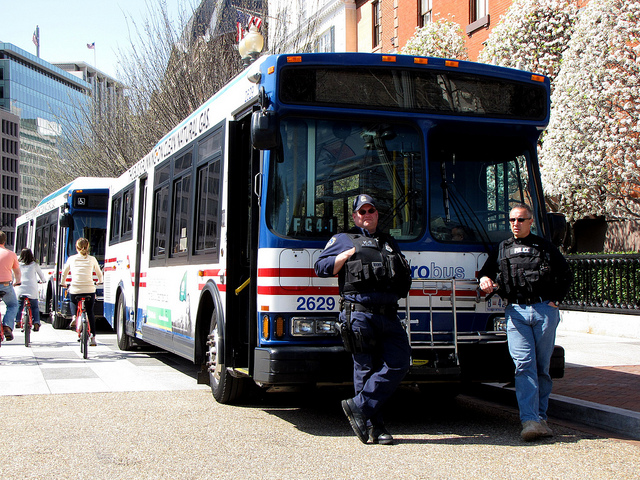Identify and read out the text in this image. 2629 robus 8 1 4 C F 